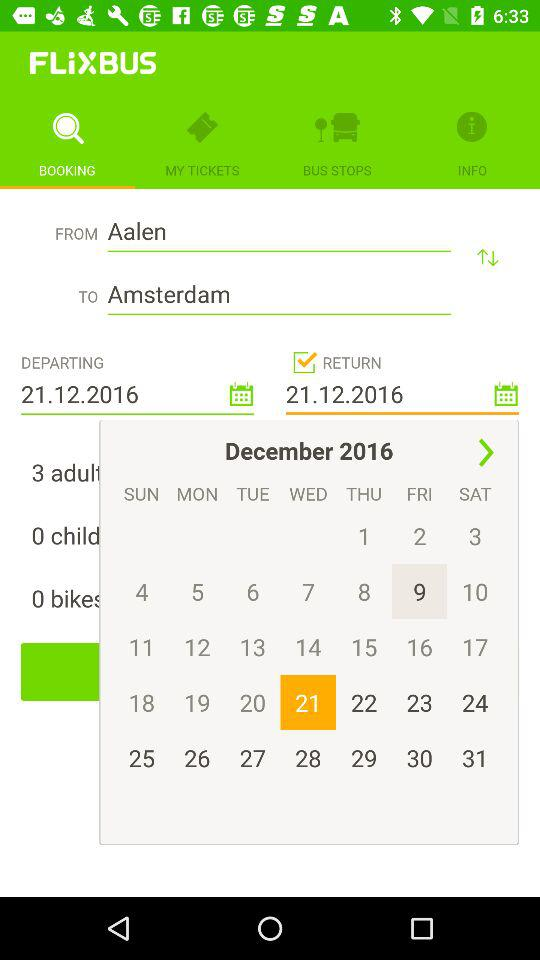What is the bus's departure city name? The departure city is Aalen. 